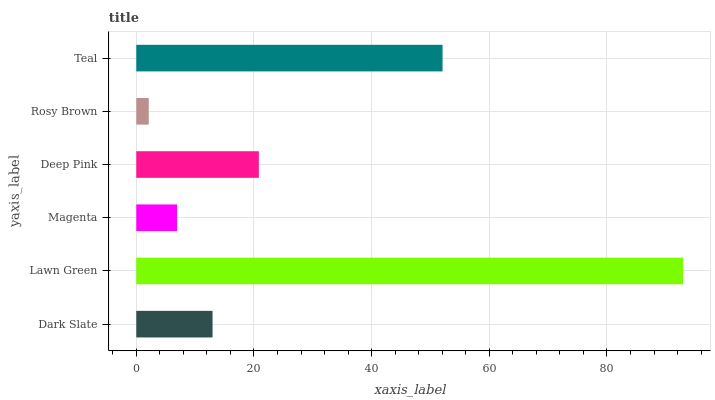Is Rosy Brown the minimum?
Answer yes or no. Yes. Is Lawn Green the maximum?
Answer yes or no. Yes. Is Magenta the minimum?
Answer yes or no. No. Is Magenta the maximum?
Answer yes or no. No. Is Lawn Green greater than Magenta?
Answer yes or no. Yes. Is Magenta less than Lawn Green?
Answer yes or no. Yes. Is Magenta greater than Lawn Green?
Answer yes or no. No. Is Lawn Green less than Magenta?
Answer yes or no. No. Is Deep Pink the high median?
Answer yes or no. Yes. Is Dark Slate the low median?
Answer yes or no. Yes. Is Rosy Brown the high median?
Answer yes or no. No. Is Lawn Green the low median?
Answer yes or no. No. 